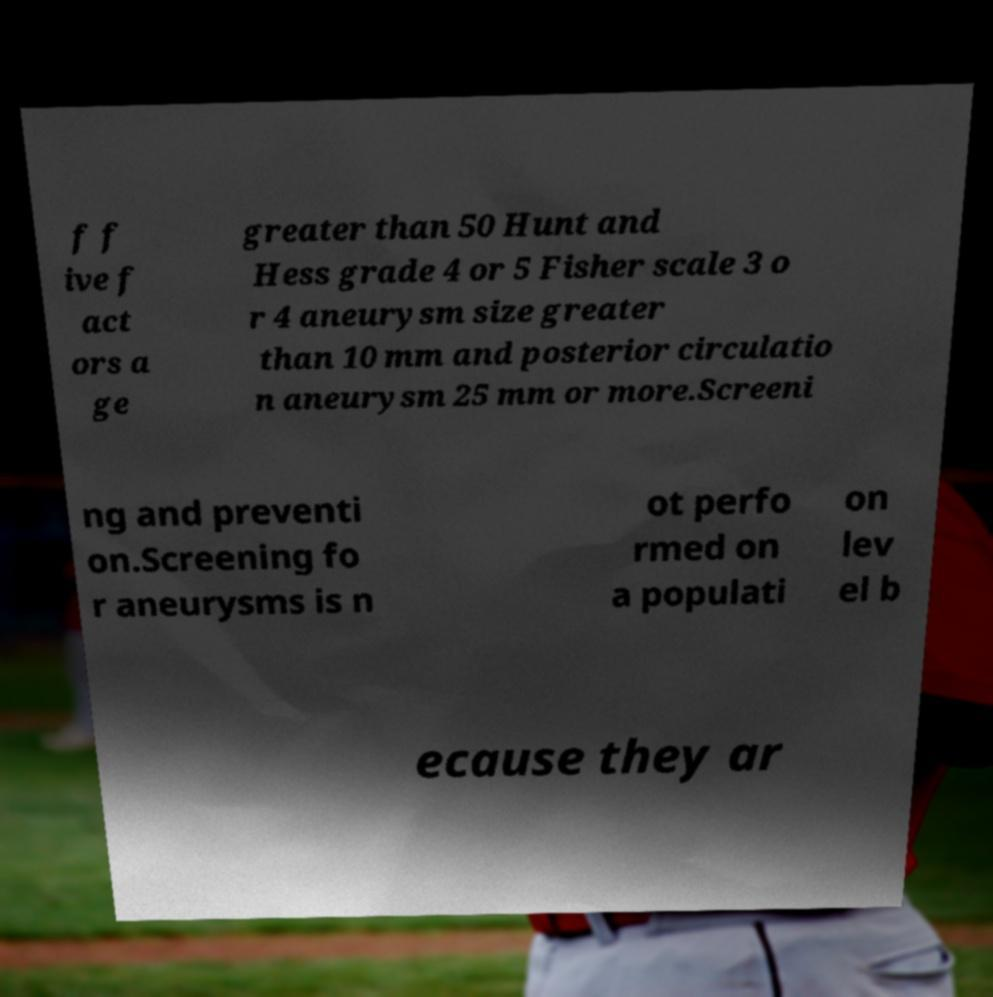Could you assist in decoding the text presented in this image and type it out clearly? f f ive f act ors a ge greater than 50 Hunt and Hess grade 4 or 5 Fisher scale 3 o r 4 aneurysm size greater than 10 mm and posterior circulatio n aneurysm 25 mm or more.Screeni ng and preventi on.Screening fo r aneurysms is n ot perfo rmed on a populati on lev el b ecause they ar 